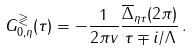<formula> <loc_0><loc_0><loc_500><loc_500>G _ { 0 , \eta } ^ { \gtrless } ( \tau ) = - \frac { 1 } { 2 \pi v } \frac { { \overline { \Delta } } _ { \eta \tau } ( 2 \pi ) } { \tau \mp i / \Lambda } \, .</formula> 